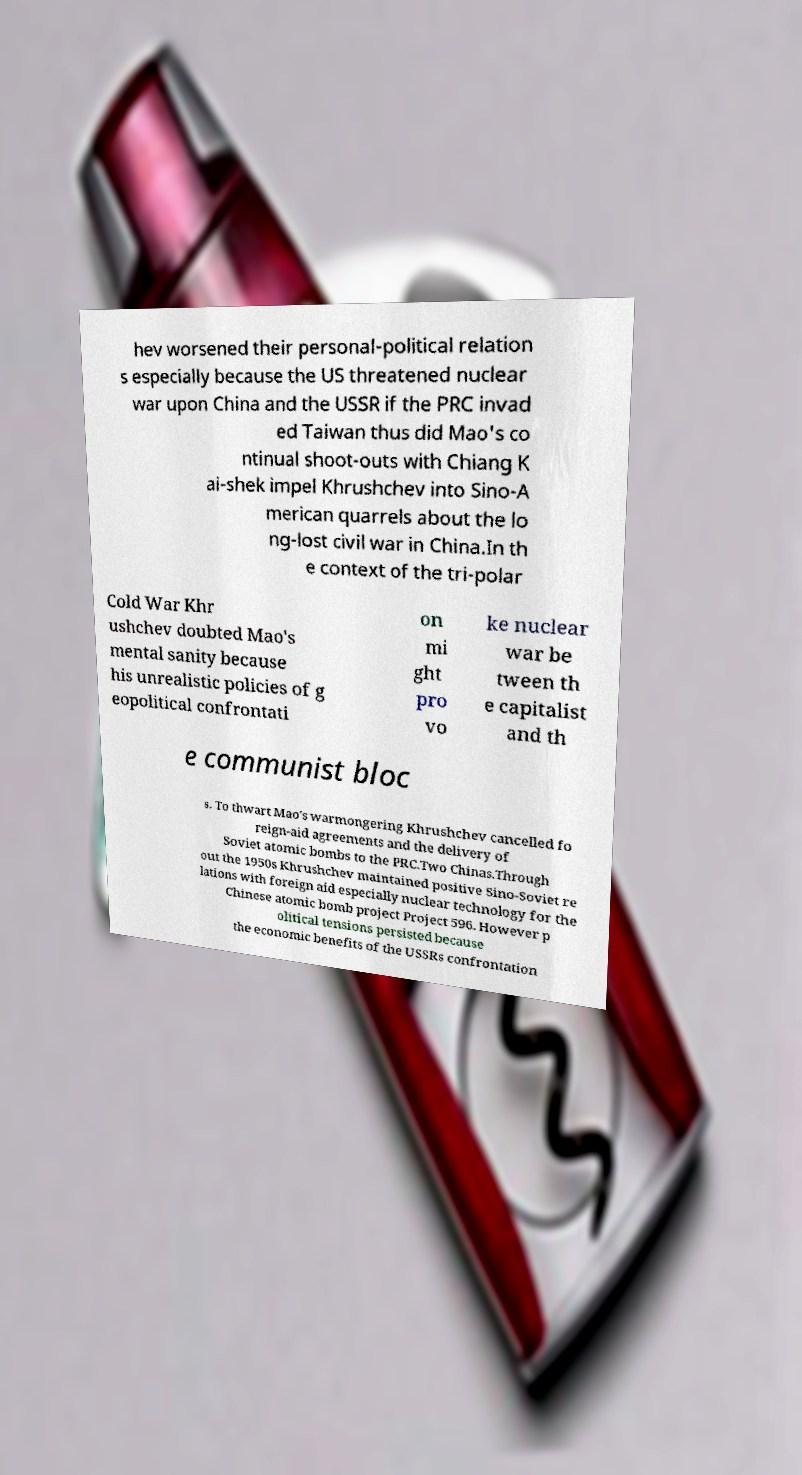Can you accurately transcribe the text from the provided image for me? hev worsened their personal-political relation s especially because the US threatened nuclear war upon China and the USSR if the PRC invad ed Taiwan thus did Mao's co ntinual shoot-outs with Chiang K ai-shek impel Khrushchev into Sino-A merican quarrels about the lo ng-lost civil war in China.In th e context of the tri-polar Cold War Khr ushchev doubted Mao's mental sanity because his unrealistic policies of g eopolitical confrontati on mi ght pro vo ke nuclear war be tween th e capitalist and th e communist bloc s. To thwart Mao's warmongering Khrushchev cancelled fo reign-aid agreements and the delivery of Soviet atomic bombs to the PRC.Two Chinas.Through out the 1950s Khrushchev maintained positive Sino-Soviet re lations with foreign aid especially nuclear technology for the Chinese atomic bomb project Project 596. However p olitical tensions persisted because the economic benefits of the USSRs confrontation 